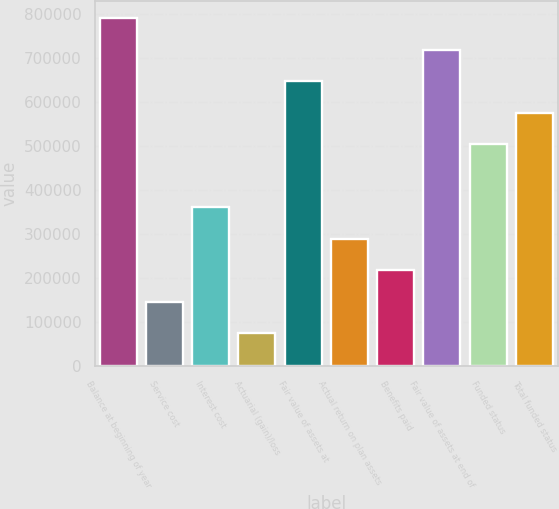<chart> <loc_0><loc_0><loc_500><loc_500><bar_chart><fcel>Balance at beginning of year<fcel>Service cost<fcel>Interest cost<fcel>Actuarial (gain)/loss<fcel>Fair value of assets at<fcel>Actual return on plan assets<fcel>Benefits paid<fcel>Fair value of assets at end of<fcel>Funded status<fcel>Total funded status<nl><fcel>790456<fcel>146341<fcel>361046<fcel>74772.4<fcel>647320<fcel>289478<fcel>217909<fcel>718888<fcel>504183<fcel>575751<nl></chart> 